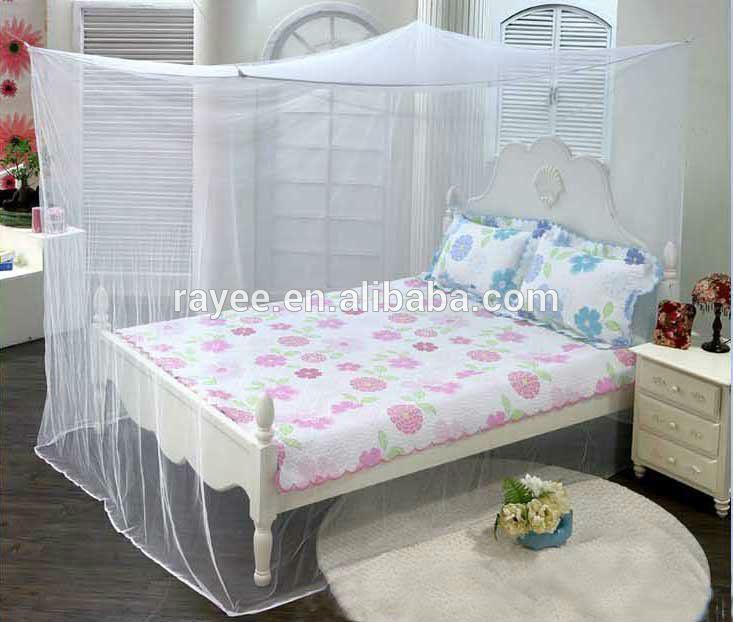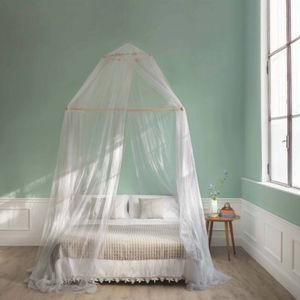The first image is the image on the left, the second image is the image on the right. Evaluate the accuracy of this statement regarding the images: "There is a round canopy bed in the right image.". Is it true? Answer yes or no. Yes. 